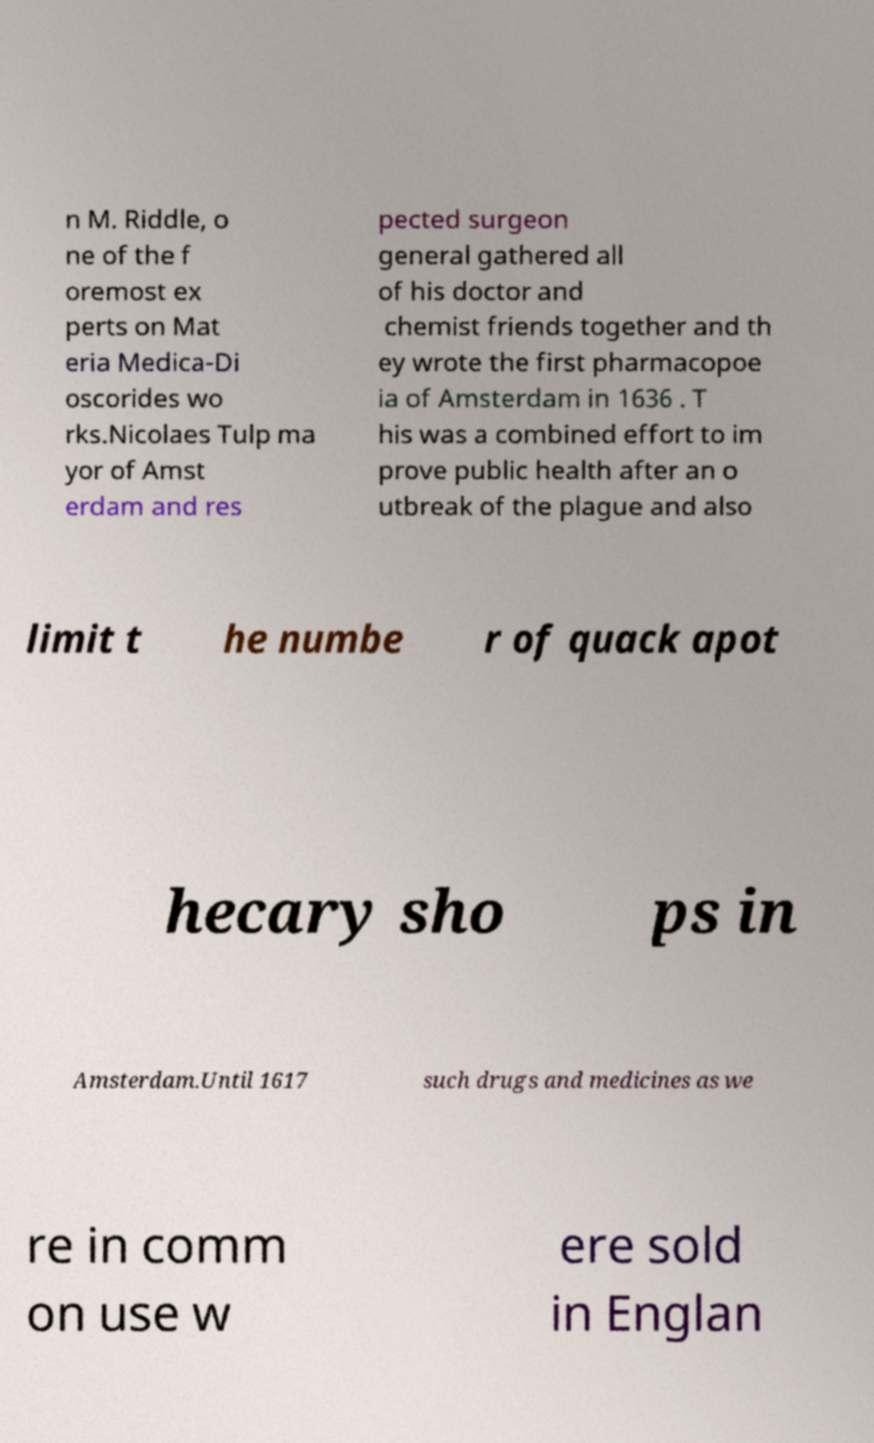I need the written content from this picture converted into text. Can you do that? n M. Riddle, o ne of the f oremost ex perts on Mat eria Medica-Di oscorides wo rks.Nicolaes Tulp ma yor of Amst erdam and res pected surgeon general gathered all of his doctor and chemist friends together and th ey wrote the first pharmacopoe ia of Amsterdam in 1636 . T his was a combined effort to im prove public health after an o utbreak of the plague and also limit t he numbe r of quack apot hecary sho ps in Amsterdam.Until 1617 such drugs and medicines as we re in comm on use w ere sold in Englan 